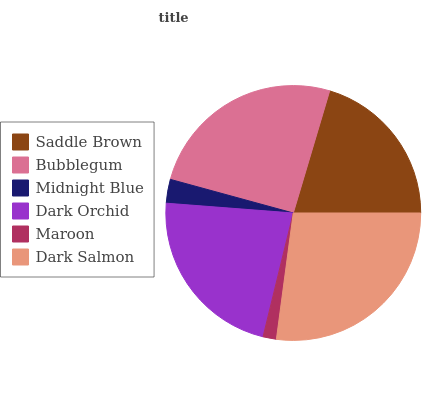Is Maroon the minimum?
Answer yes or no. Yes. Is Dark Salmon the maximum?
Answer yes or no. Yes. Is Bubblegum the minimum?
Answer yes or no. No. Is Bubblegum the maximum?
Answer yes or no. No. Is Bubblegum greater than Saddle Brown?
Answer yes or no. Yes. Is Saddle Brown less than Bubblegum?
Answer yes or no. Yes. Is Saddle Brown greater than Bubblegum?
Answer yes or no. No. Is Bubblegum less than Saddle Brown?
Answer yes or no. No. Is Dark Orchid the high median?
Answer yes or no. Yes. Is Saddle Brown the low median?
Answer yes or no. Yes. Is Dark Salmon the high median?
Answer yes or no. No. Is Midnight Blue the low median?
Answer yes or no. No. 